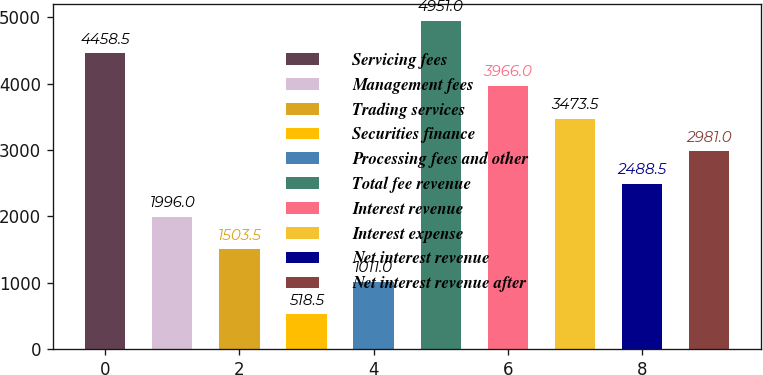Convert chart. <chart><loc_0><loc_0><loc_500><loc_500><bar_chart><fcel>Servicing fees<fcel>Management fees<fcel>Trading services<fcel>Securities finance<fcel>Processing fees and other<fcel>Total fee revenue<fcel>Interest revenue<fcel>Interest expense<fcel>Net interest revenue<fcel>Net interest revenue after<nl><fcel>4458.5<fcel>1996<fcel>1503.5<fcel>518.5<fcel>1011<fcel>4951<fcel>3966<fcel>3473.5<fcel>2488.5<fcel>2981<nl></chart> 